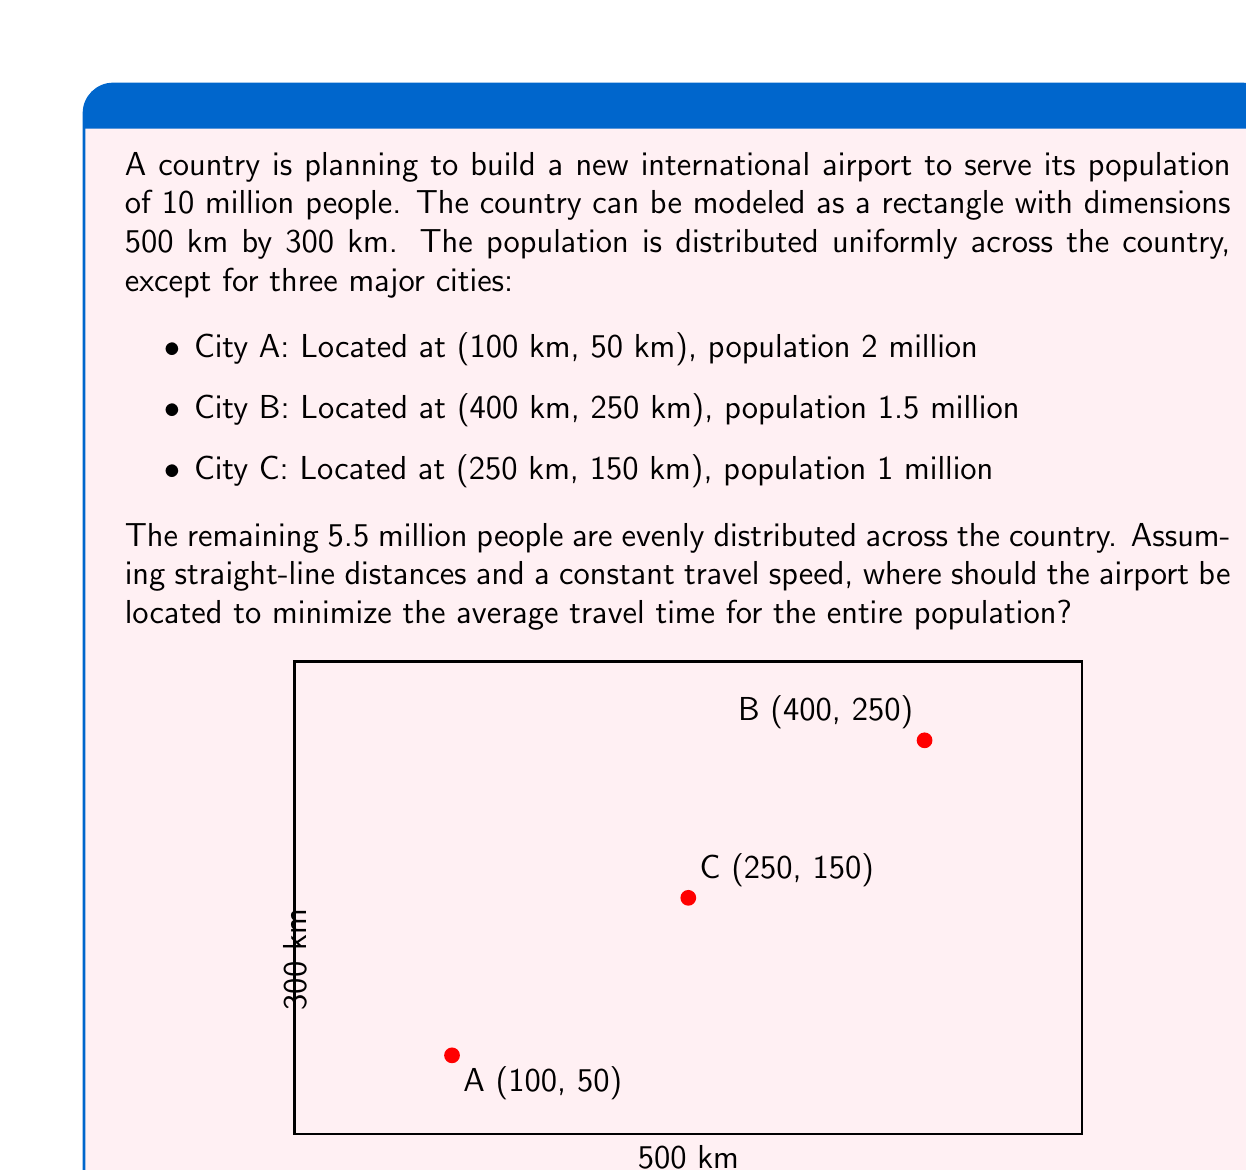Show me your answer to this math problem. To solve this optimization problem, we need to find the point that minimizes the weighted sum of distances from all population centers. This point is known as the weighted centroid.

Step 1: Calculate the weight of each population center.
- City A: 2 million / 10 million = 0.2
- City B: 1.5 million / 10 million = 0.15
- City C: 1 million / 10 million = 0.1
- Uniformly distributed population: 5.5 million / 10 million = 0.55

Step 2: For the uniformly distributed population, we can treat it as if it were concentrated at the center of the rectangle (250 km, 150 km).

Step 3: Calculate the weighted centroid using the formula:
$$(x, y) = \left(\frac{\sum w_i x_i}{\sum w_i}, \frac{\sum w_i y_i}{\sum w_i}\right)$$

Where $(x_i, y_i)$ are the coordinates of each population center, and $w_i$ is its weight.

$x = \frac{0.2(100) + 0.15(400) + 0.1(250) + 0.55(250)}{0.2 + 0.15 + 0.1 + 0.55} = 250$ km

$y = \frac{0.2(50) + 0.15(250) + 0.1(150) + 0.55(150)}{0.2 + 0.15 + 0.1 + 0.55} = 150$ km

Step 4: Verify that this point minimizes the average travel time:
The weighted centroid (250 km, 150 km) coincides with the center of the country and the location of City C. This makes sense because:
1. It's the center of mass for the uniformly distributed population.
2. It's equidistant from Cities A and B, balancing their influence.
3. It's exactly at City C, further reducing overall travel time.

Any other location would increase the average travel time for the population as a whole.
Answer: (250 km, 150 km) 